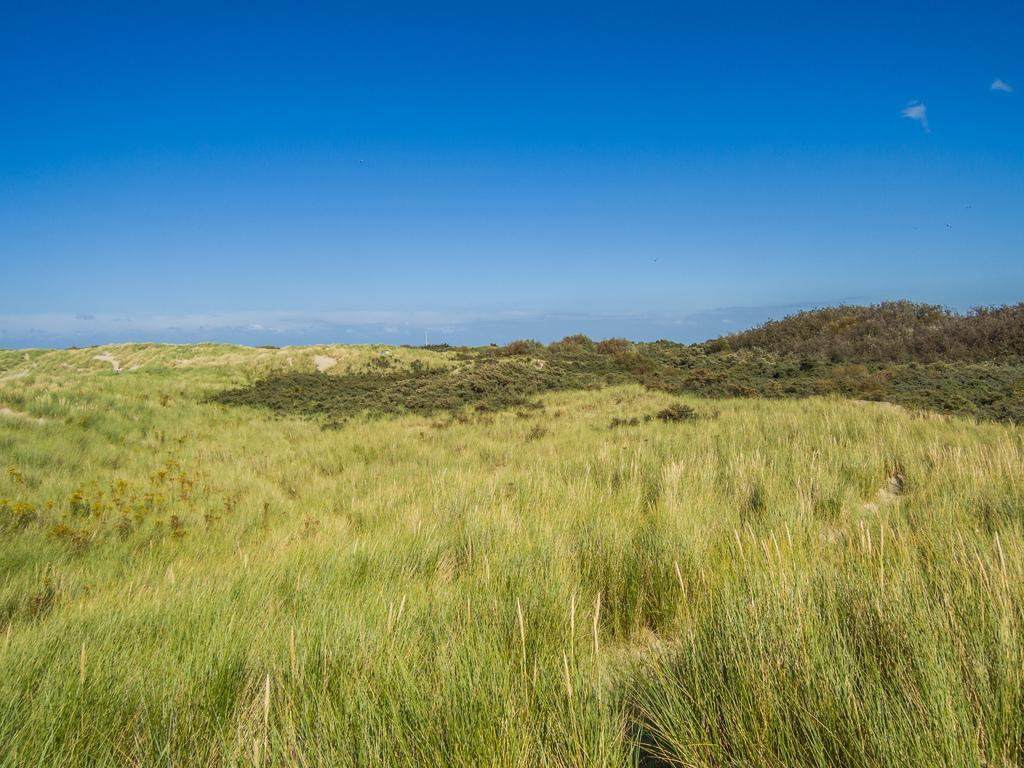What type of vegetation is present on the ground in the image? There is grass and plants on the ground in the image. What can be seen in the sky in the background of the image? There are clouds visible in the sky in the background of the image. What type of lace can be seen on the monkey's face in the image? There is no monkey or lace present in the image; it features grass, plants, and clouds. 